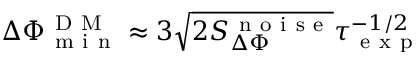<formula> <loc_0><loc_0><loc_500><loc_500>\Delta \Phi _ { m i n } ^ { D M } \approx 3 \sqrt { 2 S _ { \Delta \Phi } ^ { n o i s e } } \tau _ { e x p } ^ { - 1 / 2 }</formula> 